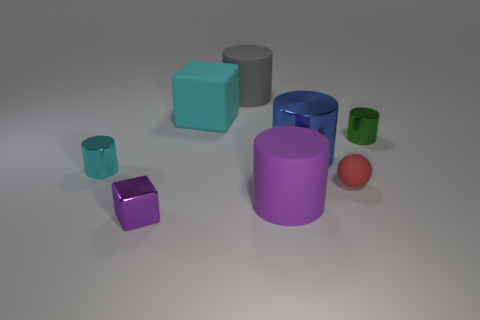Does the small object to the left of the purple cube have the same shape as the tiny red thing? No, the small object to the left of the purple cube, which is a cylinder, does not have the same shape as the tiny red sphere. 